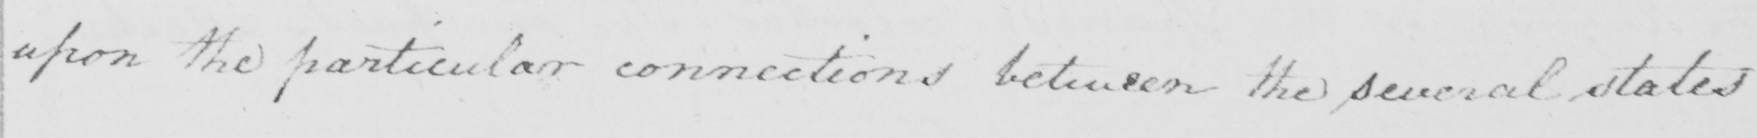Please provide the text content of this handwritten line. upon the particular connections between the several states 